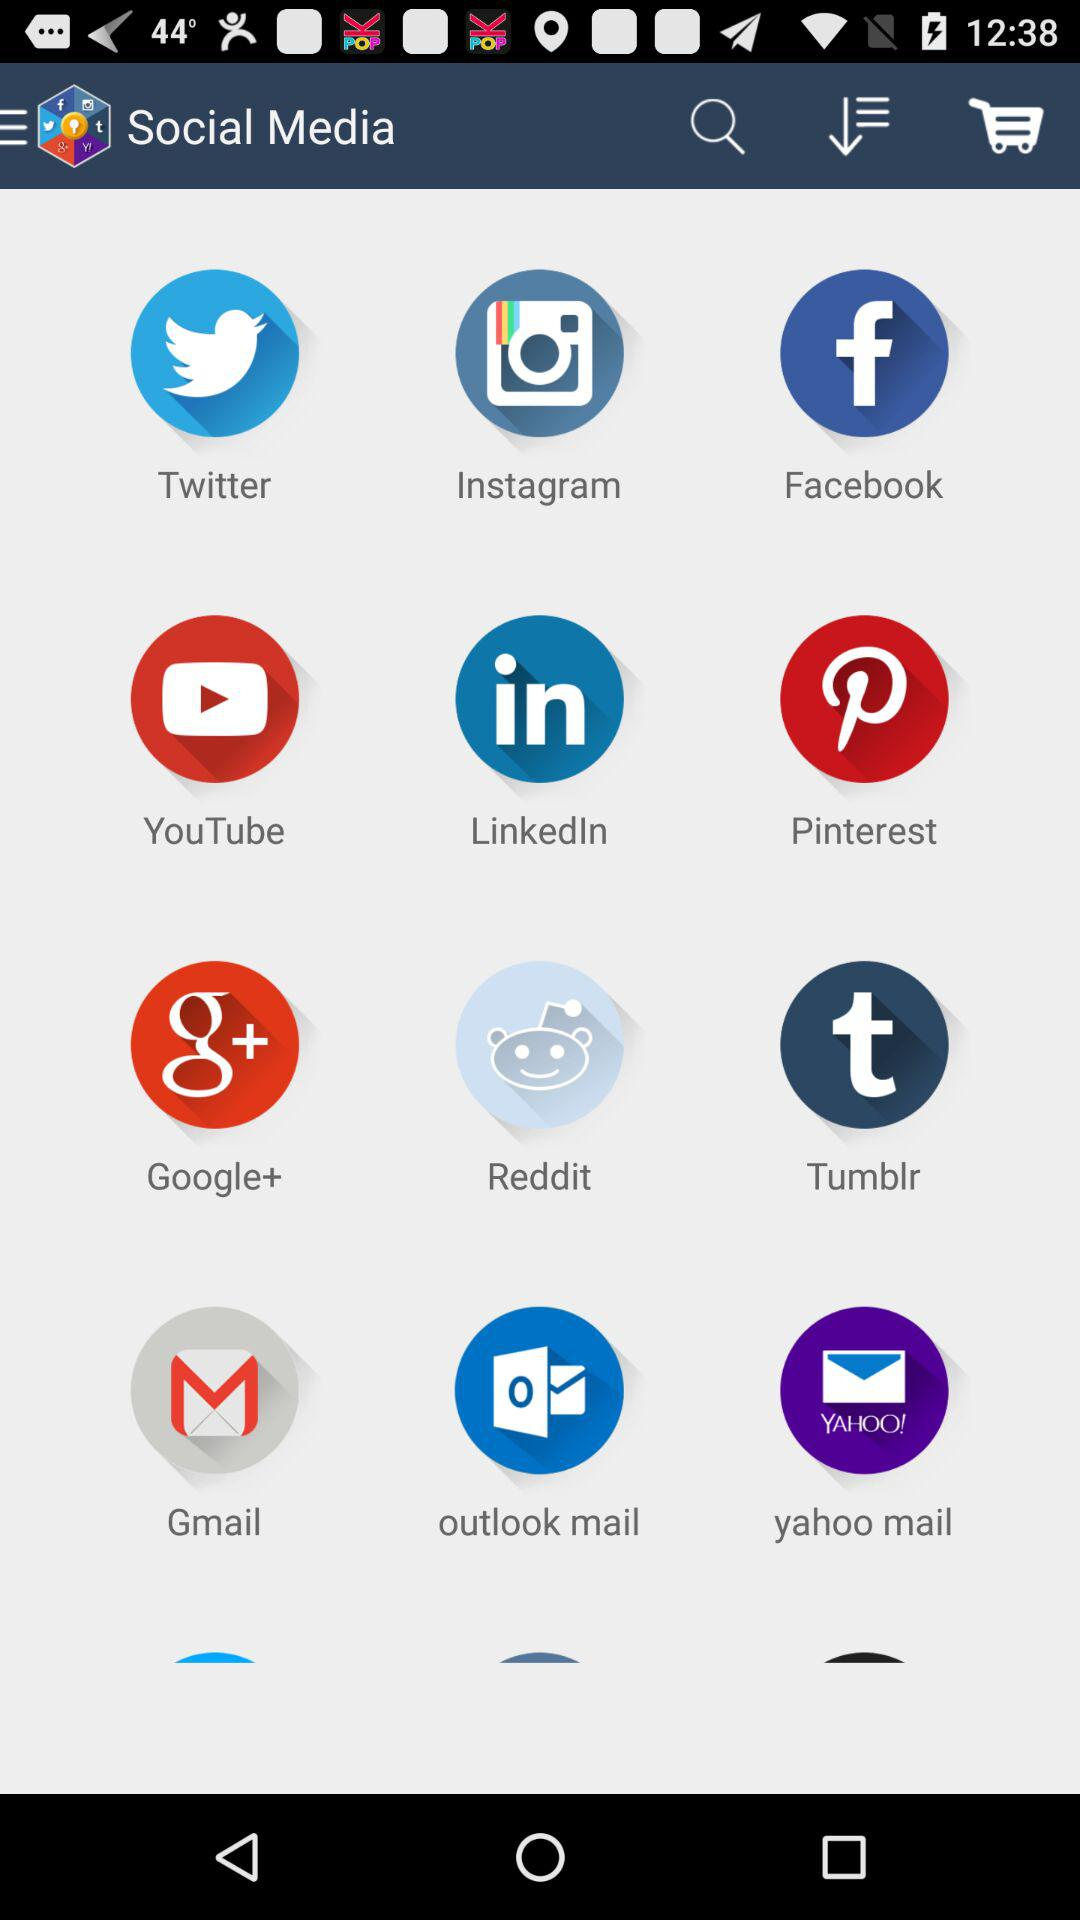How many social media applications options are there?
When the provided information is insufficient, respond with <no answer>. <no answer> 